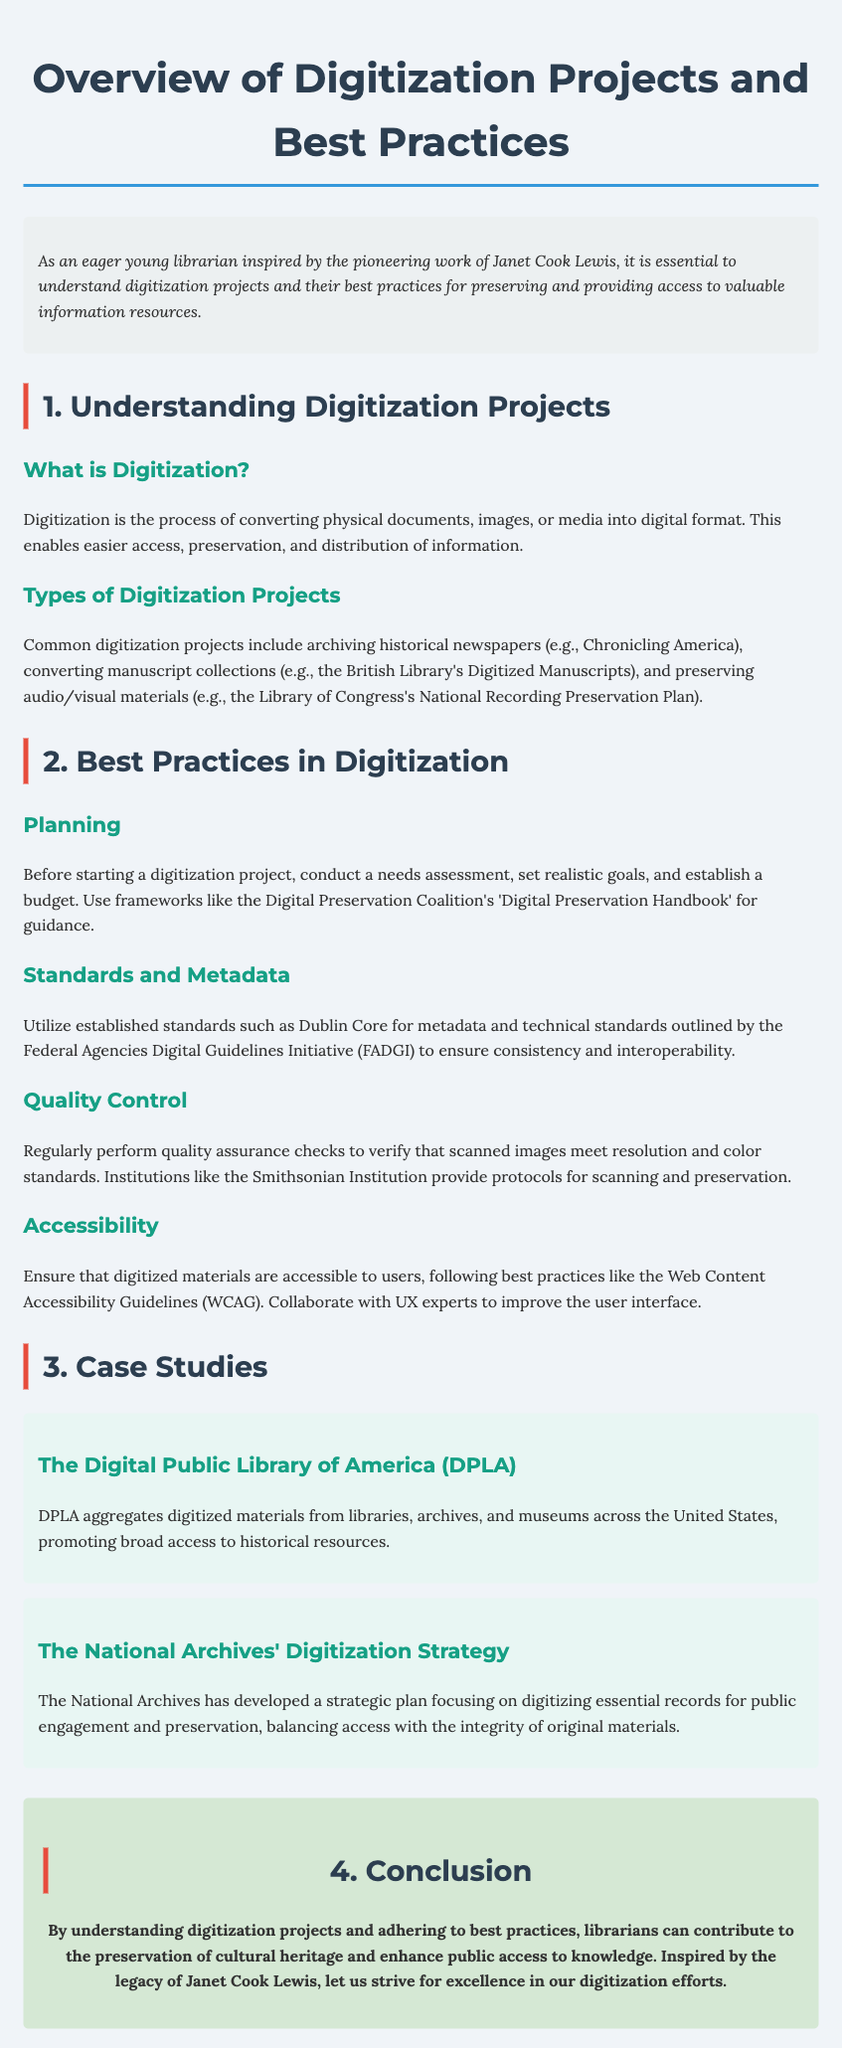What is digitization? Digitization is the process of converting physical documents, images, or media into digital format.
Answer: Converting physical documents What is the DPLA? DPLA aggregates digitized materials from libraries, archives, and museums across the United States.
Answer: Digital Public Library of America What should be assessed before starting a digitization project? Conduct a needs assessment to understand requirements for the project.
Answer: Needs assessment Which standards should be utilized for metadata? Utilize established standards such as Dublin Core for metadata.
Answer: Dublin Core What is one of the best practices for quality control? Regularly perform quality assurance checks to verify that scanned images meet resolution and color standards.
Answer: Quality assurance checks What is a focus of the National Archives' digitization strategy? The National Archives has developed a strategic plan focusing on digitizing essential records.
Answer: Digitizing essential records What guidelines should be followed to ensure accessibility? Follow best practices like the Web Content Accessibility Guidelines (WCAG).
Answer: WCAG What is the relationship between digitization and public access? Digitization enhances public access to knowledge and resources.
Answer: Enhances public access 